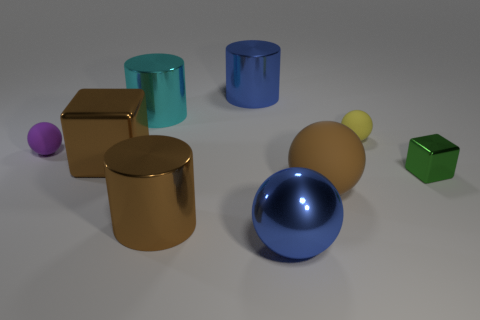Subtract 2 balls. How many balls are left? 2 Subtract all large brown cylinders. How many cylinders are left? 2 Subtract all brown spheres. How many spheres are left? 3 Subtract all red cylinders. Subtract all cyan blocks. How many cylinders are left? 3 Add 4 green cylinders. How many green cylinders exist? 4 Subtract 0 blue blocks. How many objects are left? 9 Subtract all spheres. How many objects are left? 5 Subtract all yellow cylinders. Subtract all small metal cubes. How many objects are left? 8 Add 5 big metal things. How many big metal things are left? 10 